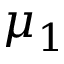Convert formula to latex. <formula><loc_0><loc_0><loc_500><loc_500>\mu _ { 1 }</formula> 